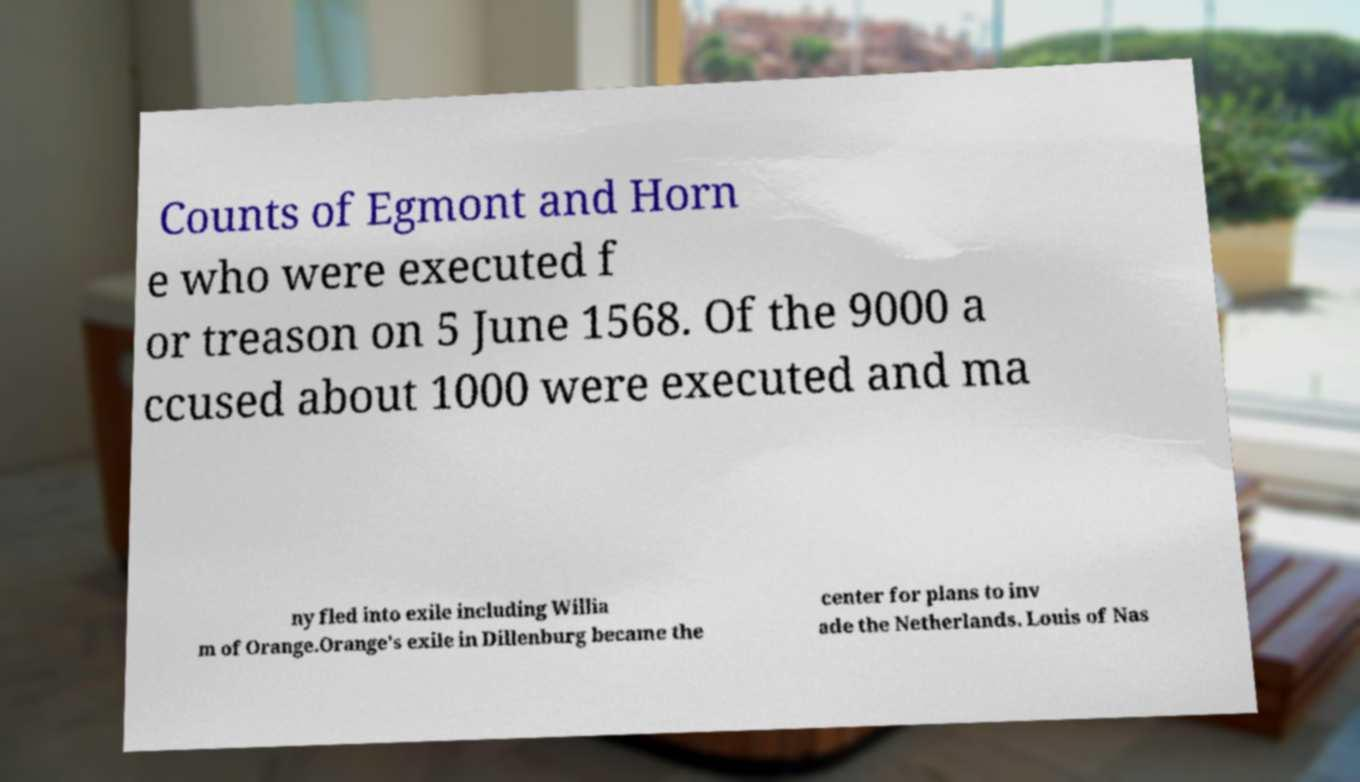What messages or text are displayed in this image? I need them in a readable, typed format. Counts of Egmont and Horn e who were executed f or treason on 5 June 1568. Of the 9000 a ccused about 1000 were executed and ma ny fled into exile including Willia m of Orange.Orange's exile in Dillenburg became the center for plans to inv ade the Netherlands. Louis of Nas 